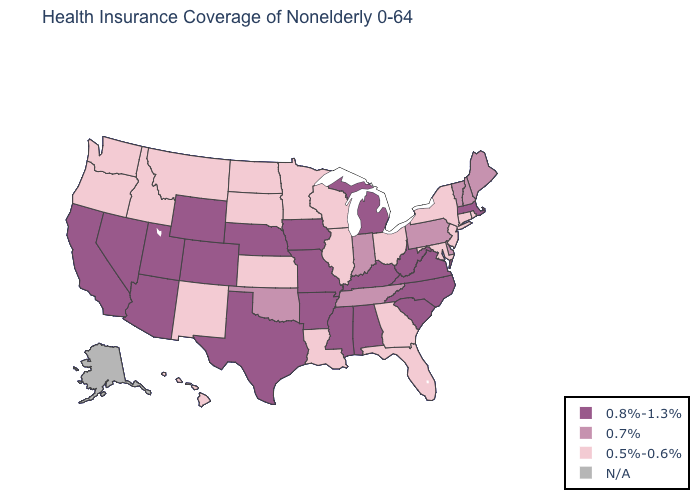Among the states that border Wisconsin , which have the highest value?
Short answer required. Iowa, Michigan. What is the value of Pennsylvania?
Write a very short answer. 0.7%. What is the highest value in the USA?
Write a very short answer. 0.8%-1.3%. What is the lowest value in the Northeast?
Give a very brief answer. 0.5%-0.6%. What is the highest value in the Northeast ?
Be succinct. 0.8%-1.3%. What is the highest value in states that border South Carolina?
Keep it brief. 0.8%-1.3%. Does Indiana have the highest value in the USA?
Be succinct. No. Name the states that have a value in the range 0.5%-0.6%?
Give a very brief answer. Connecticut, Florida, Georgia, Hawaii, Idaho, Illinois, Kansas, Louisiana, Maryland, Minnesota, Montana, New Jersey, New Mexico, New York, North Dakota, Ohio, Oregon, Rhode Island, South Dakota, Washington, Wisconsin. Is the legend a continuous bar?
Write a very short answer. No. Is the legend a continuous bar?
Write a very short answer. No. What is the lowest value in states that border South Carolina?
Short answer required. 0.5%-0.6%. Does California have the lowest value in the USA?
Give a very brief answer. No. Name the states that have a value in the range 0.5%-0.6%?
Give a very brief answer. Connecticut, Florida, Georgia, Hawaii, Idaho, Illinois, Kansas, Louisiana, Maryland, Minnesota, Montana, New Jersey, New Mexico, New York, North Dakota, Ohio, Oregon, Rhode Island, South Dakota, Washington, Wisconsin. What is the value of Delaware?
Answer briefly. 0.7%. 